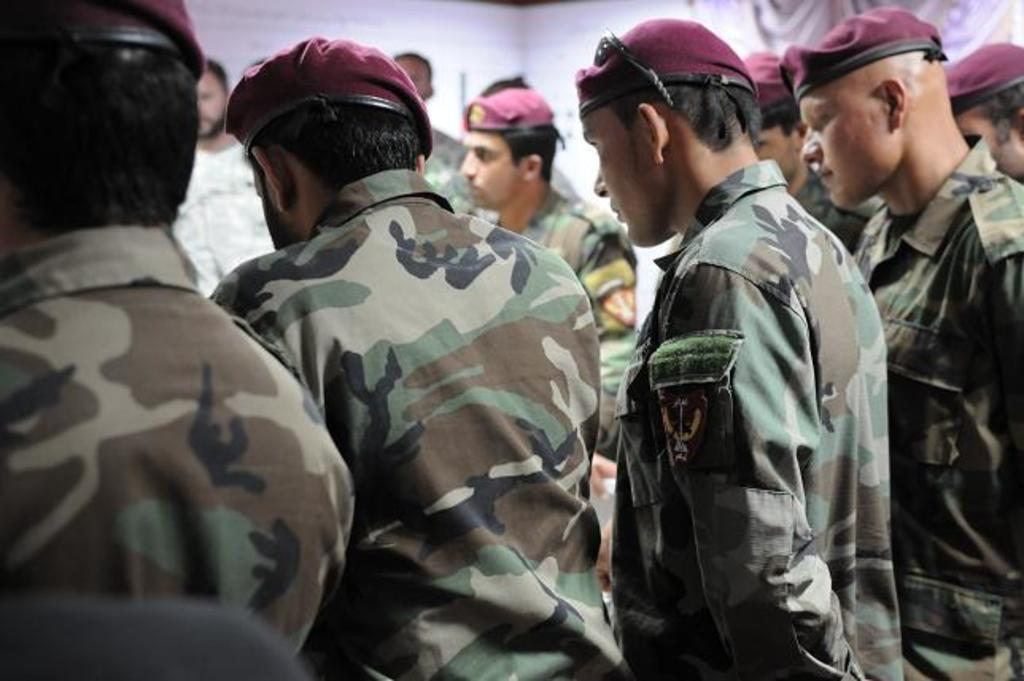Where was the image taken? The image was taken indoors. Who is present in the image? There are men standing in the image. What are the men wearing on their heads? The men are wearing caps. What type of clothing are the men wearing on their upper bodies? The men are wearing shirts. What can be seen in the background of the image? There is a wall in the background of the image, and there is a curtain on the wall. Can you tell me what the woman is doing in the image? There is no woman present in the image; it features only men. What type of work does the secretary do in the image? There is no secretary present in the image; it features only men. 